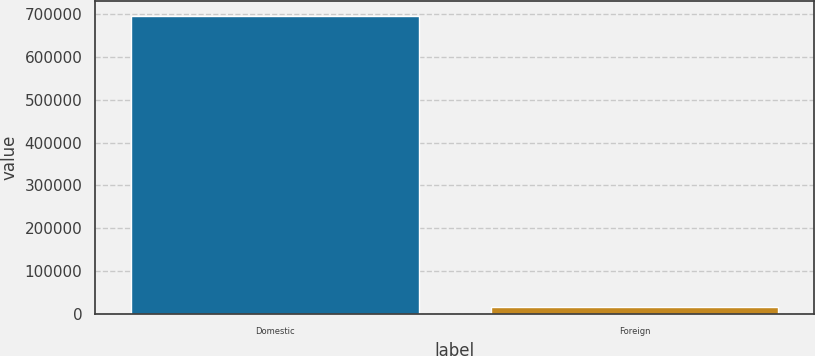Convert chart to OTSL. <chart><loc_0><loc_0><loc_500><loc_500><bar_chart><fcel>Domestic<fcel>Foreign<nl><fcel>697062<fcel>16406<nl></chart> 